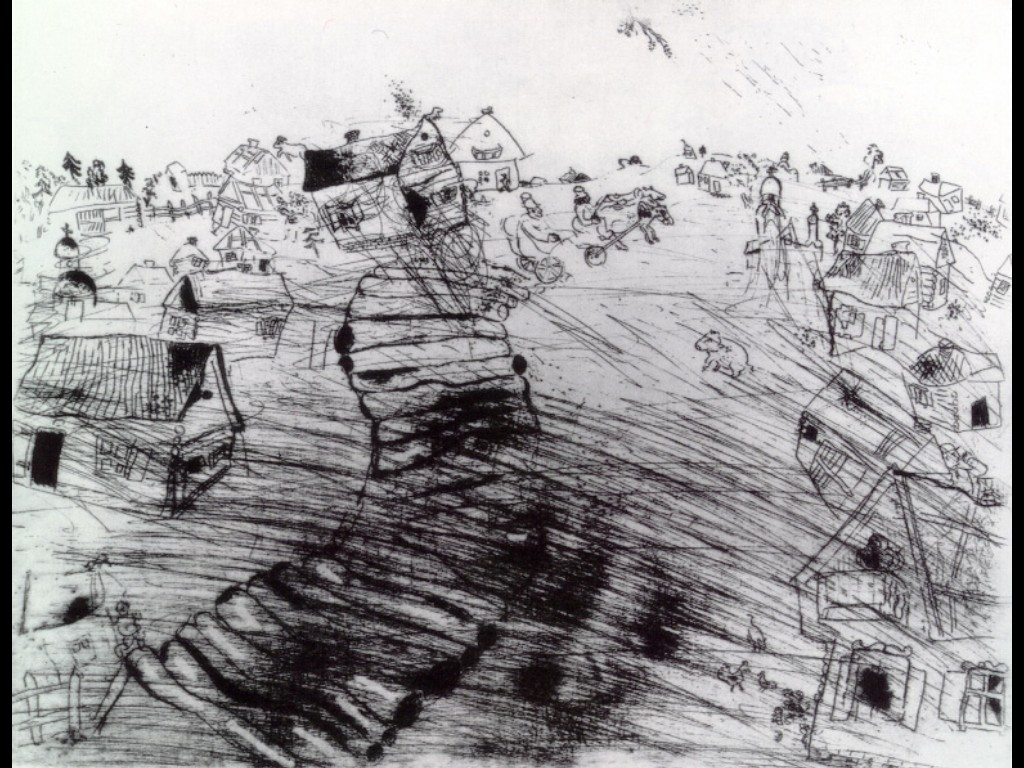Can you describe the architectural style of the buildings in the village? The buildings in this village exhibit a rustic and eclectic architectural style. Most houses appear to be modest, with simple structural forms and a combination of wood and thatched roofs. Their irregular shapes and tilting angles give a whimsical and charming appearance, reflecting perhaps an older, quaint rural tradition. The sketch captures a unique blend of different architectural elements, suggesting a village with a long history and diverse cultural influences. 